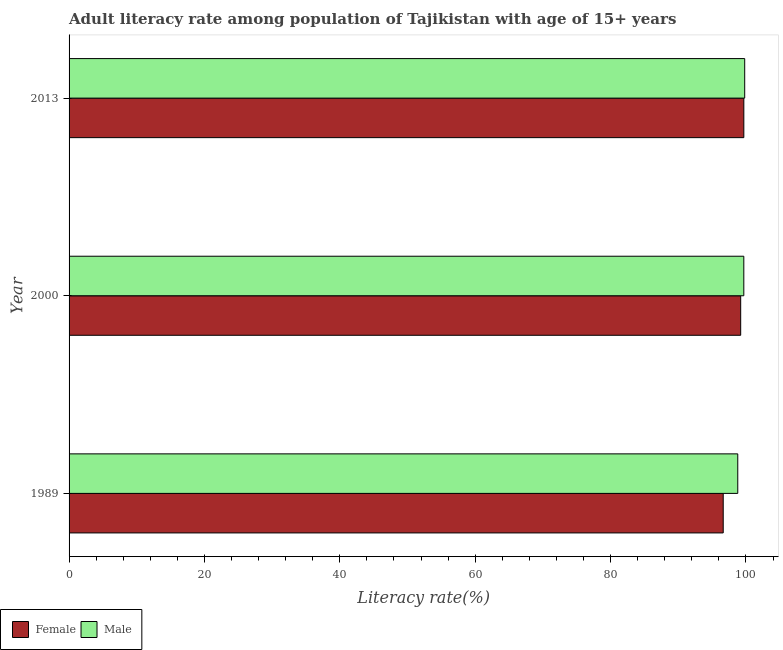How many groups of bars are there?
Make the answer very short. 3. Are the number of bars on each tick of the Y-axis equal?
Make the answer very short. Yes. How many bars are there on the 3rd tick from the top?
Keep it short and to the point. 2. How many bars are there on the 3rd tick from the bottom?
Your response must be concise. 2. What is the label of the 3rd group of bars from the top?
Your response must be concise. 1989. In how many cases, is the number of bars for a given year not equal to the number of legend labels?
Your answer should be compact. 0. What is the female adult literacy rate in 2013?
Give a very brief answer. 99.68. Across all years, what is the maximum female adult literacy rate?
Offer a very short reply. 99.68. Across all years, what is the minimum female adult literacy rate?
Your answer should be very brief. 96.64. In which year was the female adult literacy rate minimum?
Your answer should be compact. 1989. What is the total male adult literacy rate in the graph?
Offer a very short reply. 298.29. What is the difference between the female adult literacy rate in 1989 and that in 2013?
Make the answer very short. -3.04. What is the difference between the male adult literacy rate in 1989 and the female adult literacy rate in 2013?
Make the answer very short. -0.89. What is the average female adult literacy rate per year?
Provide a succinct answer. 98.52. In the year 2013, what is the difference between the male adult literacy rate and female adult literacy rate?
Your answer should be very brief. 0.13. What is the ratio of the male adult literacy rate in 1989 to that in 2013?
Your answer should be very brief. 0.99. Is the female adult literacy rate in 1989 less than that in 2000?
Offer a terse response. Yes. What is the difference between the highest and the second highest female adult literacy rate?
Provide a short and direct response. 0.46. What is the difference between the highest and the lowest female adult literacy rate?
Your response must be concise. 3.04. In how many years, is the female adult literacy rate greater than the average female adult literacy rate taken over all years?
Give a very brief answer. 2. What does the 2nd bar from the top in 2013 represents?
Provide a succinct answer. Female. What does the 1st bar from the bottom in 2013 represents?
Ensure brevity in your answer.  Female. How many bars are there?
Offer a terse response. 6. Are all the bars in the graph horizontal?
Offer a terse response. Yes. Are the values on the major ticks of X-axis written in scientific E-notation?
Ensure brevity in your answer.  No. Does the graph contain grids?
Your answer should be compact. No. How many legend labels are there?
Provide a short and direct response. 2. How are the legend labels stacked?
Provide a short and direct response. Horizontal. What is the title of the graph?
Provide a short and direct response. Adult literacy rate among population of Tajikistan with age of 15+ years. What is the label or title of the X-axis?
Ensure brevity in your answer.  Literacy rate(%). What is the label or title of the Y-axis?
Provide a succinct answer. Year. What is the Literacy rate(%) of Female in 1989?
Ensure brevity in your answer.  96.64. What is the Literacy rate(%) of Male in 1989?
Offer a very short reply. 98.79. What is the Literacy rate(%) of Female in 2000?
Provide a short and direct response. 99.22. What is the Literacy rate(%) in Male in 2000?
Keep it short and to the point. 99.68. What is the Literacy rate(%) in Female in 2013?
Offer a terse response. 99.68. What is the Literacy rate(%) in Male in 2013?
Offer a very short reply. 99.82. Across all years, what is the maximum Literacy rate(%) in Female?
Your response must be concise. 99.68. Across all years, what is the maximum Literacy rate(%) in Male?
Make the answer very short. 99.82. Across all years, what is the minimum Literacy rate(%) of Female?
Ensure brevity in your answer.  96.64. Across all years, what is the minimum Literacy rate(%) of Male?
Provide a succinct answer. 98.79. What is the total Literacy rate(%) of Female in the graph?
Keep it short and to the point. 295.55. What is the total Literacy rate(%) of Male in the graph?
Offer a very short reply. 298.29. What is the difference between the Literacy rate(%) in Female in 1989 and that in 2000?
Your response must be concise. -2.58. What is the difference between the Literacy rate(%) of Male in 1989 and that in 2000?
Give a very brief answer. -0.89. What is the difference between the Literacy rate(%) of Female in 1989 and that in 2013?
Your answer should be very brief. -3.04. What is the difference between the Literacy rate(%) in Male in 1989 and that in 2013?
Your response must be concise. -1.03. What is the difference between the Literacy rate(%) of Female in 2000 and that in 2013?
Offer a terse response. -0.46. What is the difference between the Literacy rate(%) of Male in 2000 and that in 2013?
Give a very brief answer. -0.13. What is the difference between the Literacy rate(%) in Female in 1989 and the Literacy rate(%) in Male in 2000?
Give a very brief answer. -3.04. What is the difference between the Literacy rate(%) in Female in 1989 and the Literacy rate(%) in Male in 2013?
Your response must be concise. -3.17. What is the difference between the Literacy rate(%) in Female in 2000 and the Literacy rate(%) in Male in 2013?
Your answer should be compact. -0.59. What is the average Literacy rate(%) in Female per year?
Ensure brevity in your answer.  98.52. What is the average Literacy rate(%) of Male per year?
Provide a short and direct response. 99.43. In the year 1989, what is the difference between the Literacy rate(%) of Female and Literacy rate(%) of Male?
Ensure brevity in your answer.  -2.15. In the year 2000, what is the difference between the Literacy rate(%) in Female and Literacy rate(%) in Male?
Offer a terse response. -0.46. In the year 2013, what is the difference between the Literacy rate(%) of Female and Literacy rate(%) of Male?
Your answer should be very brief. -0.13. What is the ratio of the Literacy rate(%) in Male in 1989 to that in 2000?
Give a very brief answer. 0.99. What is the ratio of the Literacy rate(%) in Female in 1989 to that in 2013?
Offer a terse response. 0.97. What is the difference between the highest and the second highest Literacy rate(%) in Female?
Ensure brevity in your answer.  0.46. What is the difference between the highest and the second highest Literacy rate(%) in Male?
Provide a succinct answer. 0.13. What is the difference between the highest and the lowest Literacy rate(%) in Female?
Your answer should be very brief. 3.04. What is the difference between the highest and the lowest Literacy rate(%) of Male?
Offer a terse response. 1.03. 